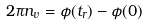<formula> <loc_0><loc_0><loc_500><loc_500>2 \pi n _ { v } = \phi ( t _ { r } ) - \phi ( 0 )</formula> 